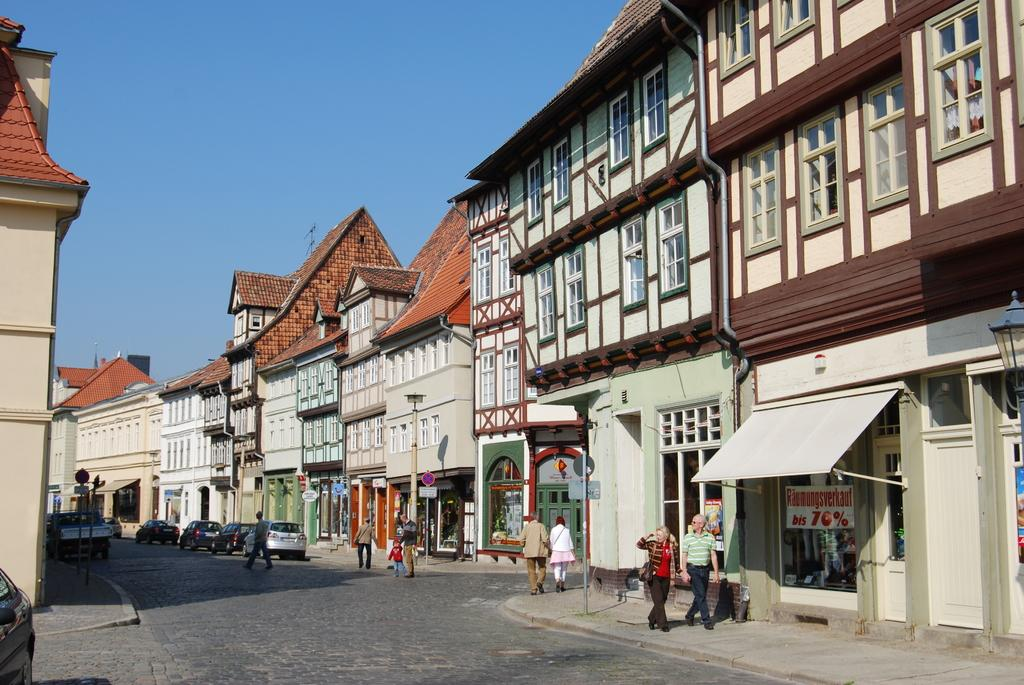What types of structures can be seen in the image? There are buildings in the image. What else can be seen in the image besides buildings? There are vehicles, poles, boards, windows, doors, and people visible in the image. Can you describe the vehicles in the image? The specific types of vehicles are not mentioned, but they are present in the image. What is visible in the background of the image? The sky is visible in the background of the image. Where is the drain located in the image? There is no drain present in the image. What type of stick is being used by the people in the image? There is no stick being used by the people in the image. 